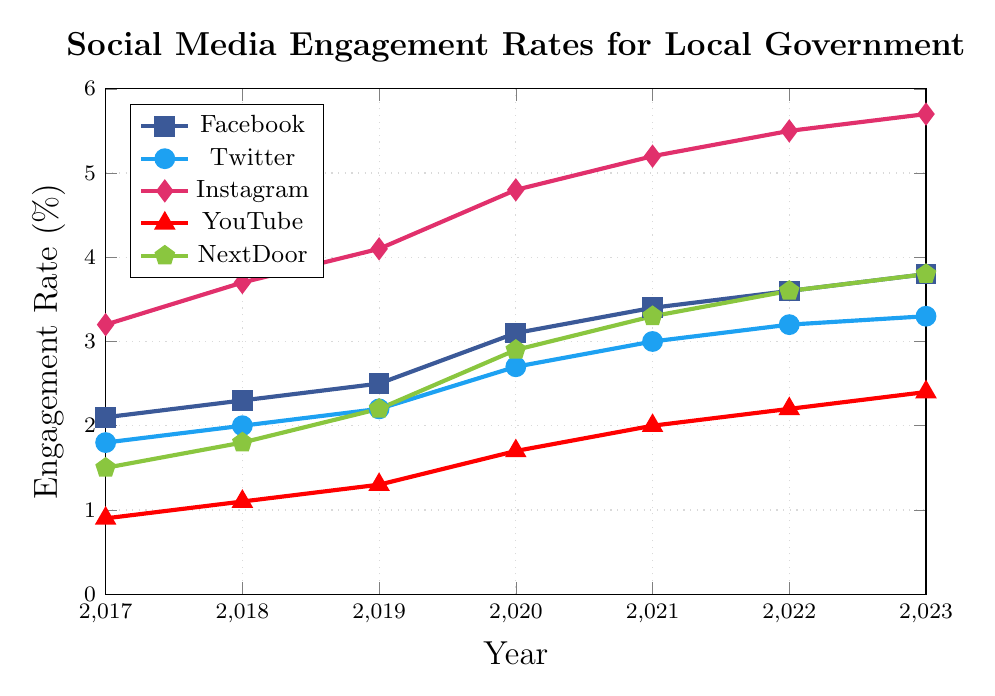Which platform shows the highest engagement rate in 2023? To answer this, look at the engagement rates for each platform in the year 2023 and identify which has the highest value. Instagram has the highest engagement rate at 5.7% in 2023.
Answer: Instagram How did Twitter's engagement rate change from 2017 to 2023? To find this, compare Twitter's engagement rate in 2017 (1.8%) to that in 2023 (3.3%). The change is 3.3% - 1.8% = 1.5%.
Answer: Increased by 1.5% Which platform had the most consistent growth in engagement rates from 2017 to 2023? Examine the trends in the engagement rates for each platform over the years and look for the one with the most steady increase. Instagram shows a consistently increasing trajectory with smooth increments each year.
Answer: Instagram By how much did Facebook's engagement rate increase from 2021 to 2023? Check Facebook's engagement rates for the years 2021 (3.4%) and 2023 (3.8%). The difference is 3.8% - 3.4% = 0.4%.
Answer: 0.4% Which two platforms had the same engagement rate in 2023? Compare the engagement rates of all the platforms in 2023. Both Facebook and NextDoor have the same engagement rate of 3.8% in 2023.
Answer: Facebook and NextDoor What is the total increase in engagement rate for YouTube from 2017 to 2023? Examine YouTube's engagement rates in 2017 (0.9%) and in 2023 (2.4%). The total increase is 2.4% - 0.9% = 1.5%.
Answer: 1.5% Which platform had the largest increase in engagement rate between any two consecutive years? Compare the year-over-year changes for all platforms. The largest increase is Instagram from 2019 (4.1%) to 2020 (4.8%), an increase of 0.7%.
Answer: Instagram from 2019 to 2020 What was the average engagement rate for Instagram from 2017 to 2023? Calculate the average by summing Instagram's yearly rates and dividing by the number of years. The sum (3.2% + 3.7% + 4.1% + 4.8% + 5.2% + 5.5% + 5.7%) = 32.2%, and the average is 32.2%/7 ≈ 4.6%.
Answer: 4.6% Which platform had a higher engagement rate in 2019, Facebook or Twitter? Compare Facebook's rate (2.5%) and Twitter's rate (2.2%) in 2019. Facebook's engagement rate was higher.
Answer: Facebook 